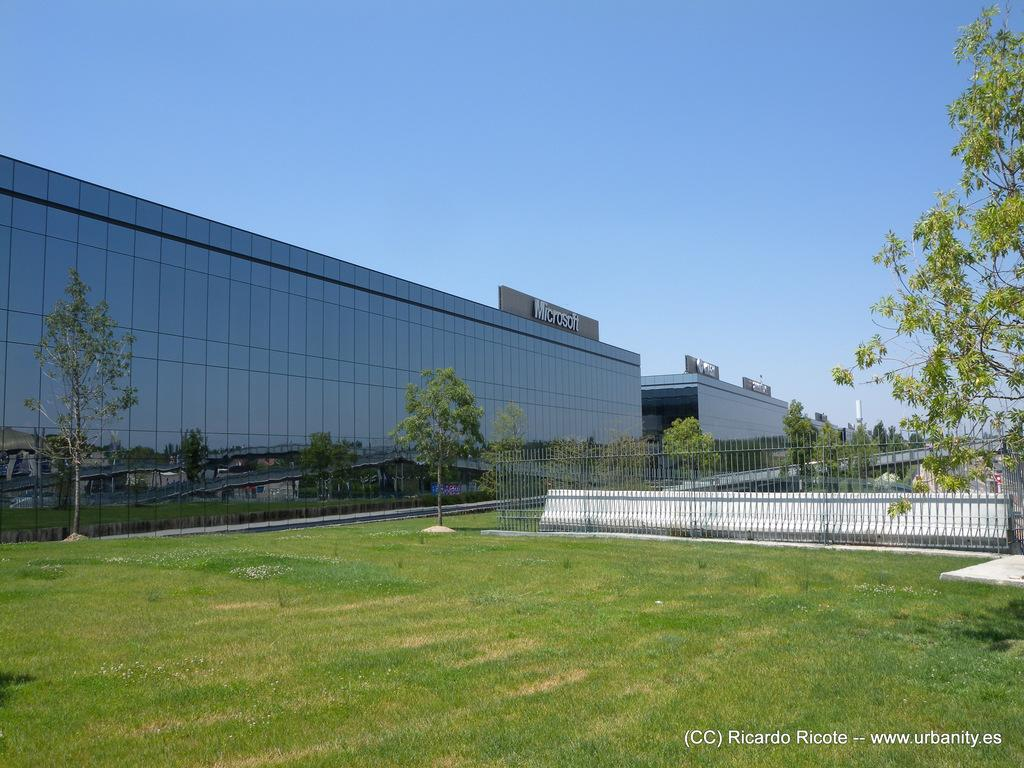What can be seen at the bottom of the image? The ground is visible in the image. What is present near the edge of the image? There is a railing in the image. What type of natural environment is visible in the background of the image? There are many trees in the background of the image. What type of man-made structure is visible in the background of the image? There is a building in the background of the image. What is the color of the sky in the image? The sky is visible in the image and has a blue color. What type of lift can be seen in the image? There is no lift present in the image. What attraction is visible in the background of the image? There is no specific attraction visible in the image; only trees, a building, and the sky are present. 